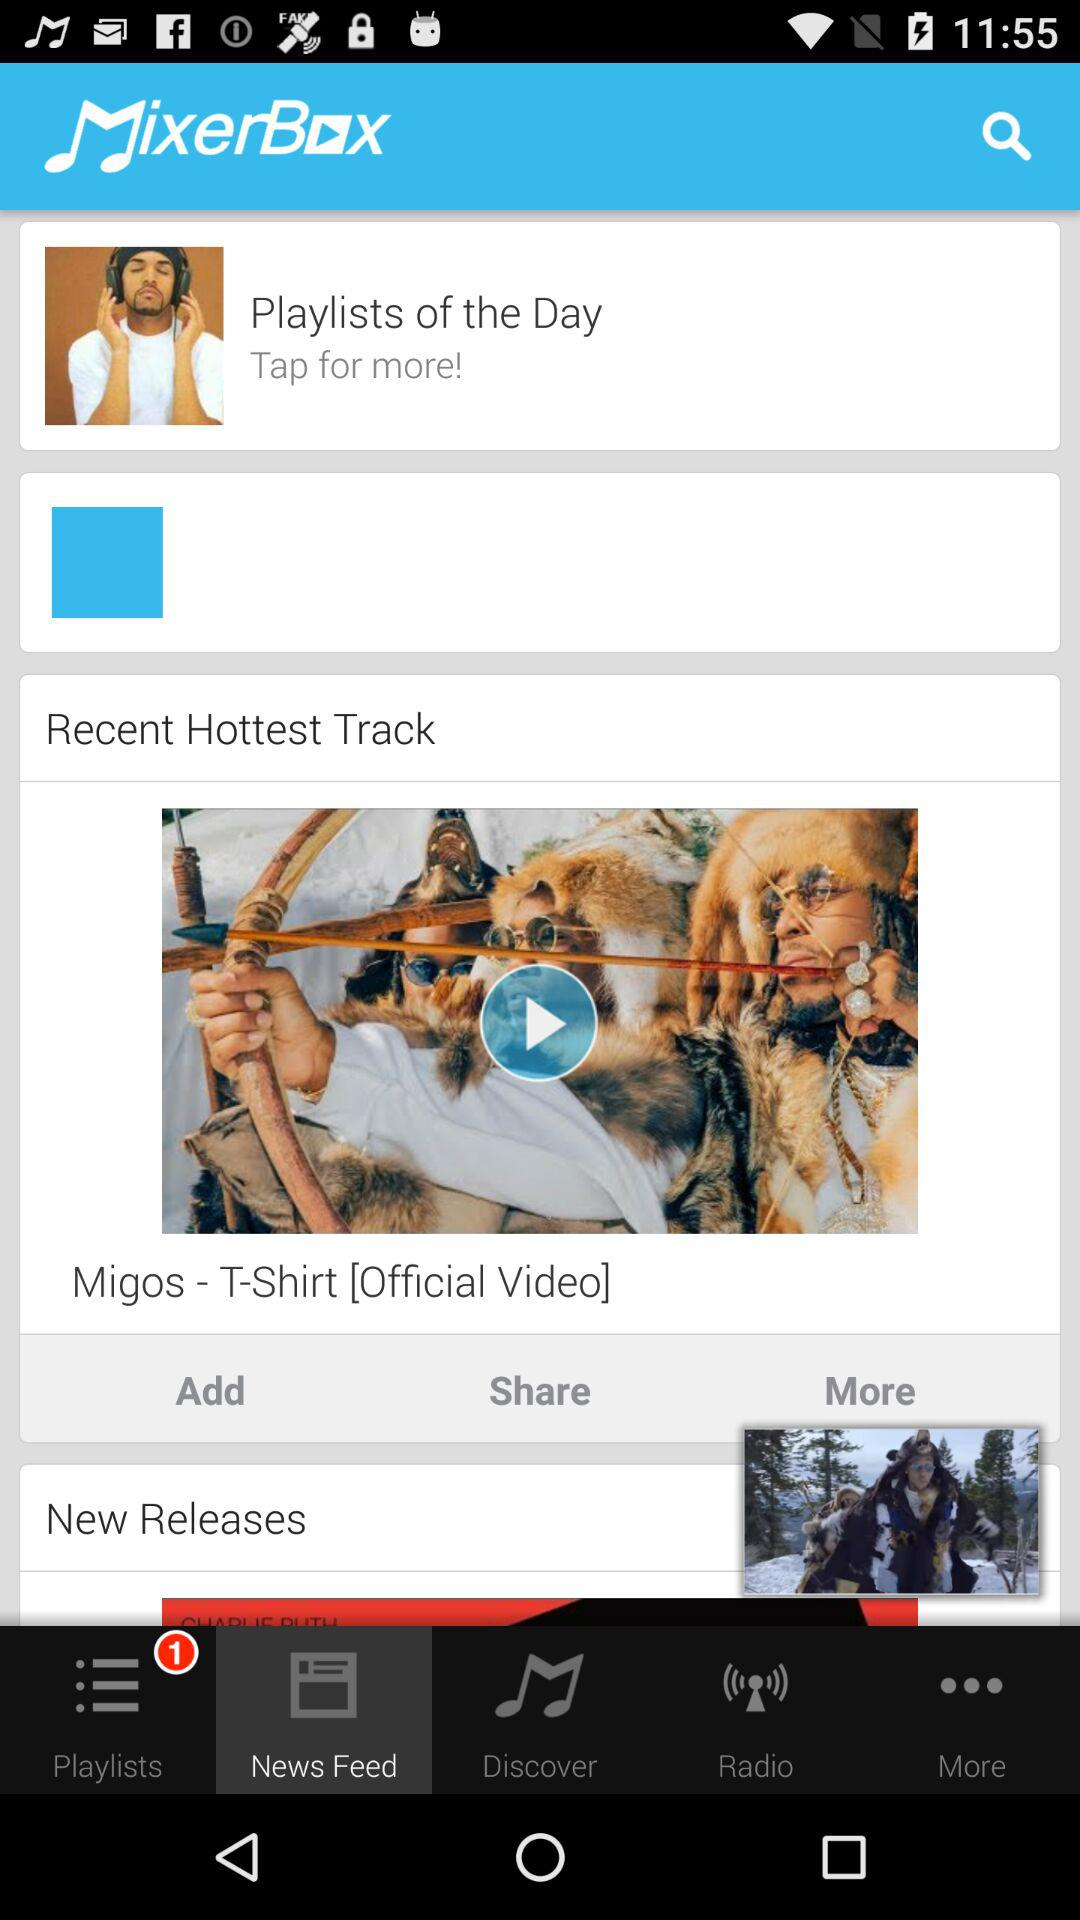What is the recent hottest track? The recent hottest track is "Migos - T-Shirt [Official Video]". 